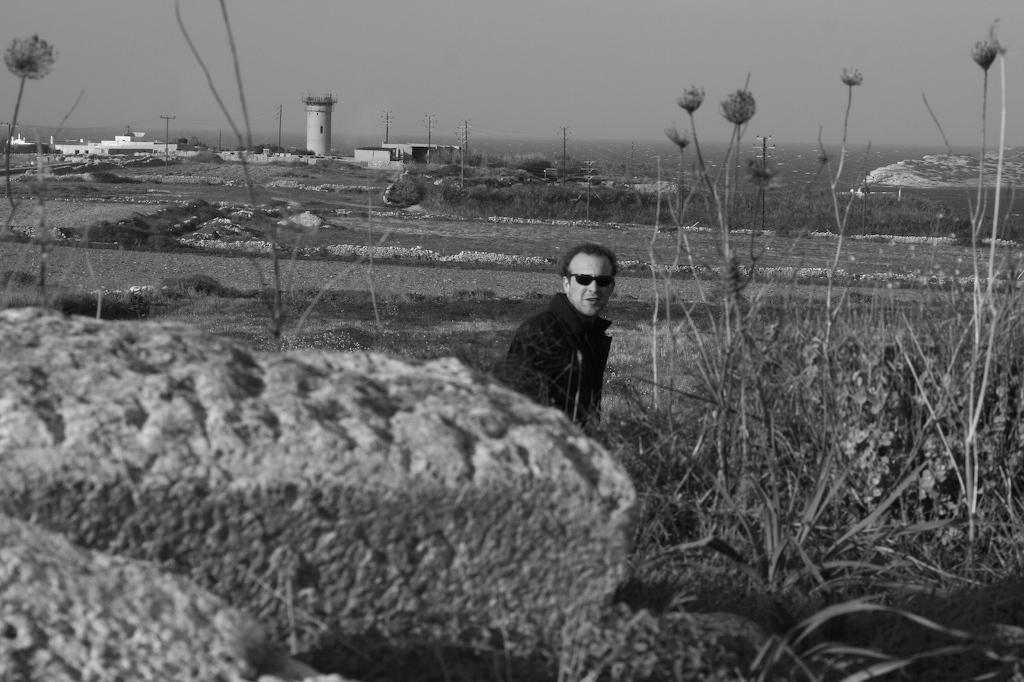What is the color scheme of the image? The image is black and white. Who is present in the image? There is a man in the image. What is the man doing in the image? The man is looking to one side. What is the man wearing in the image? The man is wearing a coat and spectacles. What type of natural scenery can be seen in the image? There are trees in the image. How does the man increase the plot of the story in the image? The image is not a story, and there is no plot to increase. The man is simply looking to one side in a black and white image with trees in the background. 